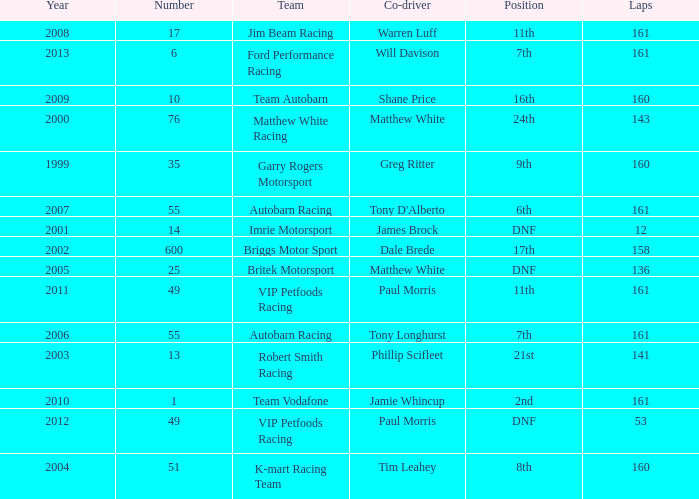Help me parse the entirety of this table. {'header': ['Year', 'Number', 'Team', 'Co-driver', 'Position', 'Laps'], 'rows': [['2008', '17', 'Jim Beam Racing', 'Warren Luff', '11th', '161'], ['2013', '6', 'Ford Performance Racing', 'Will Davison', '7th', '161'], ['2009', '10', 'Team Autobarn', 'Shane Price', '16th', '160'], ['2000', '76', 'Matthew White Racing', 'Matthew White', '24th', '143'], ['1999', '35', 'Garry Rogers Motorsport', 'Greg Ritter', '9th', '160'], ['2007', '55', 'Autobarn Racing', "Tony D'Alberto", '6th', '161'], ['2001', '14', 'Imrie Motorsport', 'James Brock', 'DNF', '12'], ['2002', '600', 'Briggs Motor Sport', 'Dale Brede', '17th', '158'], ['2005', '25', 'Britek Motorsport', 'Matthew White', 'DNF', '136'], ['2011', '49', 'VIP Petfoods Racing', 'Paul Morris', '11th', '161'], ['2006', '55', 'Autobarn Racing', 'Tony Longhurst', '7th', '161'], ['2003', '13', 'Robert Smith Racing', 'Phillip Scifleet', '21st', '141'], ['2010', '1', 'Team Vodafone', 'Jamie Whincup', '2nd', '161'], ['2012', '49', 'VIP Petfoods Racing', 'Paul Morris', 'DNF', '53'], ['2004', '51', 'K-mart Racing Team', 'Tim Leahey', '8th', '160']]} Who was the co-driver for the team with more than 160 laps and the number 6 after 2010? Will Davison. 